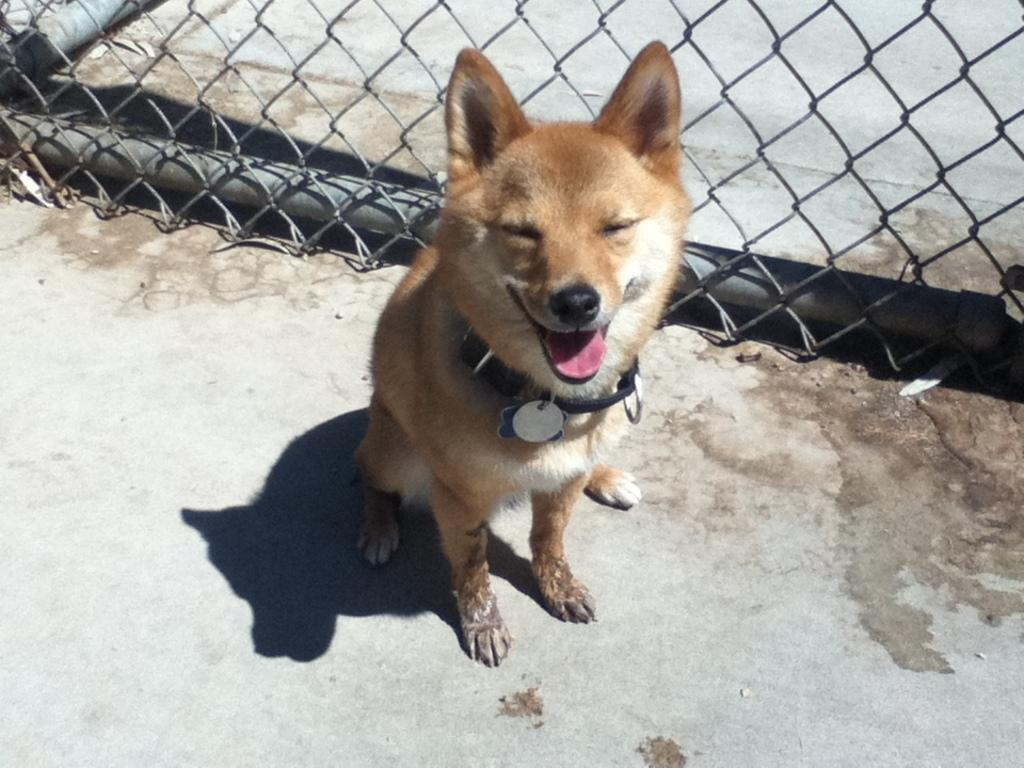What is the main subject in the foreground of the image? There is a dog in the foreground of the image. What is the dog doing in the image? The dog is sitting on the road. What can be seen in the background of the image? There is fencing in the background of the image. What type of currency is being exchanged between the dog and the fencing in the image? There is no exchange of currency or any interaction between the dog and the fencing in the image. 